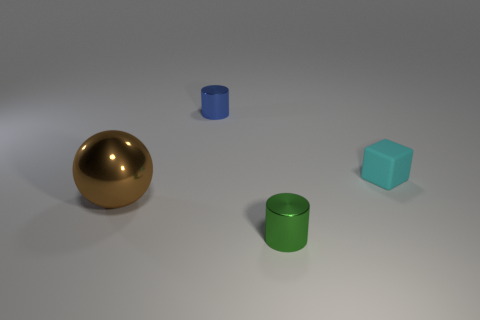How does the lighting in this image affect the perception of the different objects? The lighting in this image creates a soft shadow beneath each object, emphasizing their three-dimensional form. It also highlights the reflective quality of the shiny cylinders and the golden sphere while giving the cube a more diffused appearance due to its matte finish. 